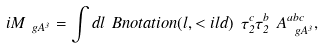<formula> <loc_0><loc_0><loc_500><loc_500>i M _ { \ g A ^ { 3 } } = \int d l \ B n o t a t i o n ( l , < i l d ) \ \tau _ { 2 } ^ { c } \tau _ { 2 } ^ { b } \ A _ { \ g A ^ { 3 } } ^ { a b c } ,</formula> 